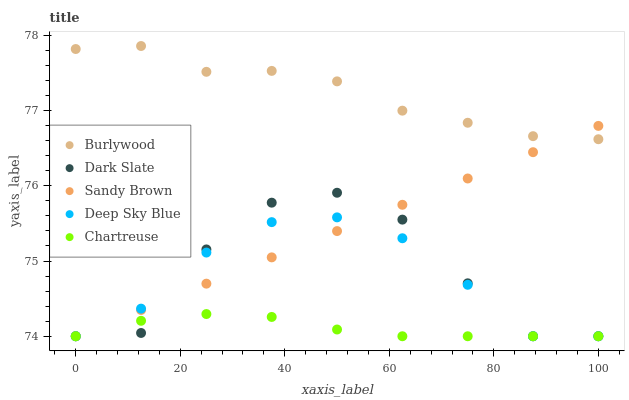Does Chartreuse have the minimum area under the curve?
Answer yes or no. Yes. Does Burlywood have the maximum area under the curve?
Answer yes or no. Yes. Does Dark Slate have the minimum area under the curve?
Answer yes or no. No. Does Dark Slate have the maximum area under the curve?
Answer yes or no. No. Is Sandy Brown the smoothest?
Answer yes or no. Yes. Is Dark Slate the roughest?
Answer yes or no. Yes. Is Chartreuse the smoothest?
Answer yes or no. No. Is Chartreuse the roughest?
Answer yes or no. No. Does Dark Slate have the lowest value?
Answer yes or no. Yes. Does Burlywood have the highest value?
Answer yes or no. Yes. Does Dark Slate have the highest value?
Answer yes or no. No. Is Dark Slate less than Burlywood?
Answer yes or no. Yes. Is Burlywood greater than Deep Sky Blue?
Answer yes or no. Yes. Does Burlywood intersect Sandy Brown?
Answer yes or no. Yes. Is Burlywood less than Sandy Brown?
Answer yes or no. No. Is Burlywood greater than Sandy Brown?
Answer yes or no. No. Does Dark Slate intersect Burlywood?
Answer yes or no. No. 